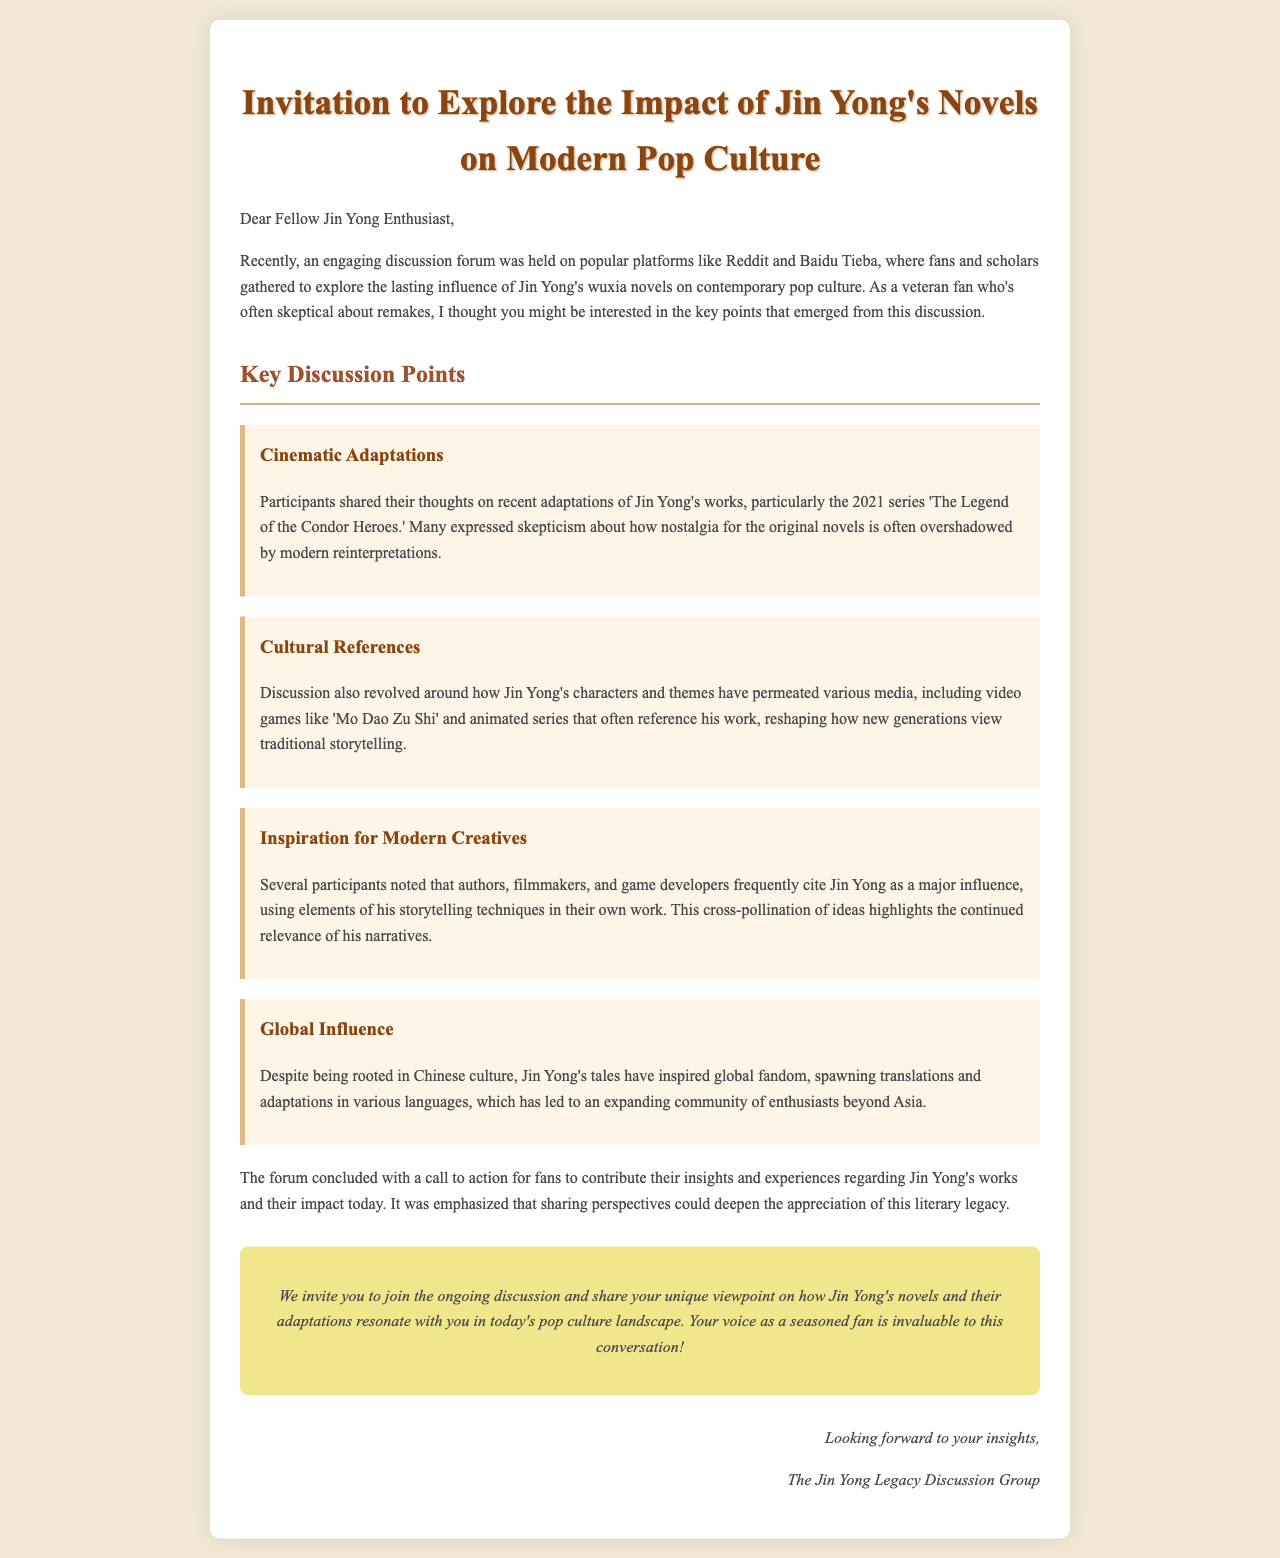What year was 'The Legend of the Condor Heroes' series released? The document mentions the 2021 series 'The Legend of the Condor Heroes' specifically.
Answer: 2021 Which video game is referenced in the discussion regarding Jin Yong's impact? The document states that 'Mo Dao Zu Shi' was mentioned in relation to how Jin Yong's characters and themes have permeated media.
Answer: Mo Dao Zu Shi What is a key theme discussed in the forum related to Jin Yong's works? The document highlights that how nostalgia for the original novels is overshadowed by modern reinterpretations is a key theme of the discussion.
Answer: Nostalgia How does the document categorize the participants' views on adaptations? The document notes that many expressed skepticism about how nostalgia for the original novels is often overshadowed by modern reinterpretations, indicating a critical view.
Answer: Skepticism What does the invitation encourage fans to share? The document mentions that fans are invited to contribute their insights and experiences regarding Jin Yong's works and their impact today.
Answer: Insights and experiences 